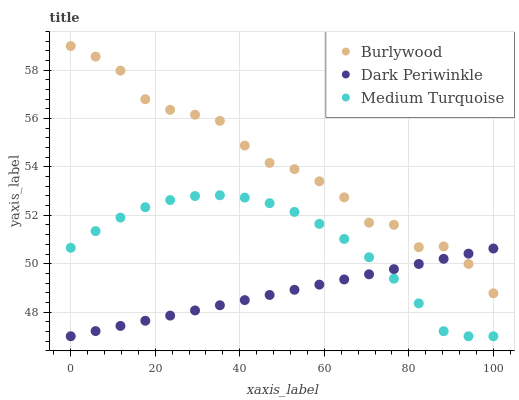Does Dark Periwinkle have the minimum area under the curve?
Answer yes or no. Yes. Does Burlywood have the maximum area under the curve?
Answer yes or no. Yes. Does Medium Turquoise have the minimum area under the curve?
Answer yes or no. No. Does Medium Turquoise have the maximum area under the curve?
Answer yes or no. No. Is Dark Periwinkle the smoothest?
Answer yes or no. Yes. Is Burlywood the roughest?
Answer yes or no. Yes. Is Medium Turquoise the smoothest?
Answer yes or no. No. Is Medium Turquoise the roughest?
Answer yes or no. No. Does Dark Periwinkle have the lowest value?
Answer yes or no. Yes. Does Burlywood have the highest value?
Answer yes or no. Yes. Does Medium Turquoise have the highest value?
Answer yes or no. No. Is Medium Turquoise less than Burlywood?
Answer yes or no. Yes. Is Burlywood greater than Medium Turquoise?
Answer yes or no. Yes. Does Dark Periwinkle intersect Medium Turquoise?
Answer yes or no. Yes. Is Dark Periwinkle less than Medium Turquoise?
Answer yes or no. No. Is Dark Periwinkle greater than Medium Turquoise?
Answer yes or no. No. Does Medium Turquoise intersect Burlywood?
Answer yes or no. No. 